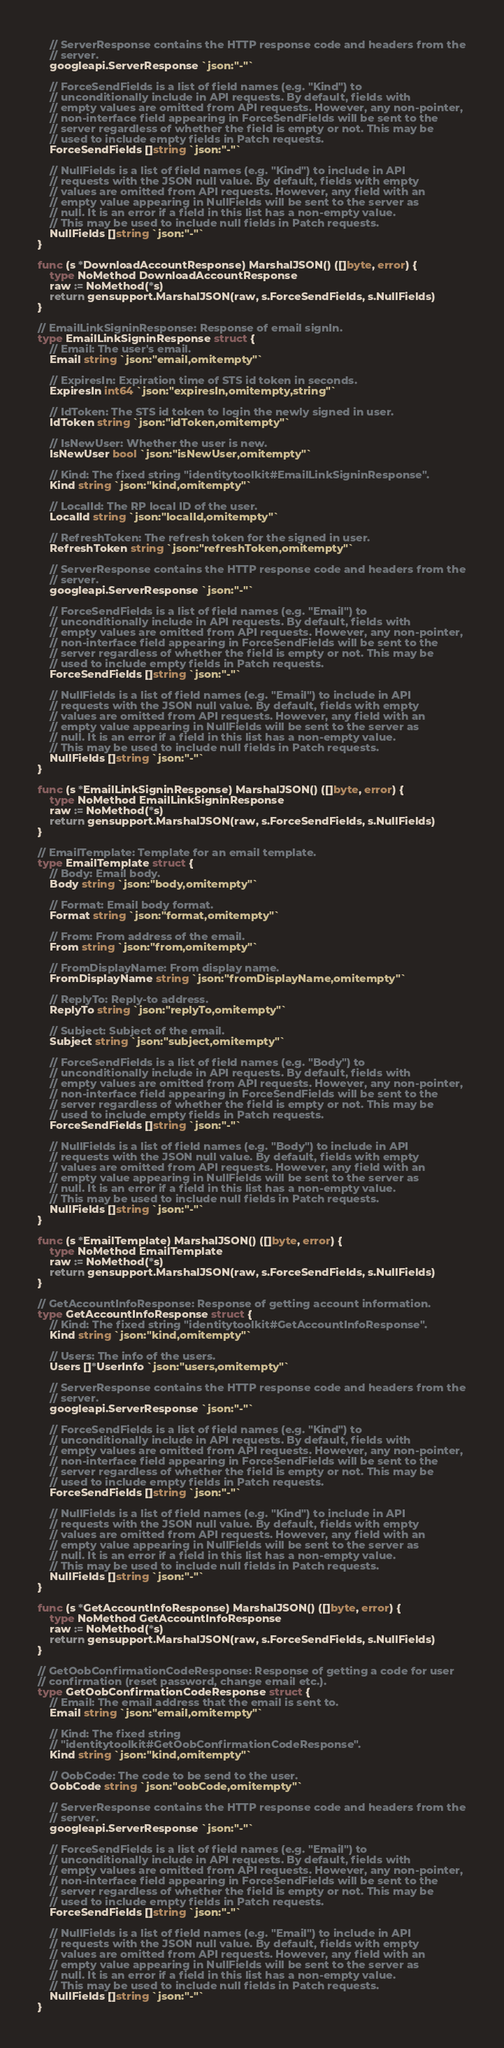Convert code to text. <code><loc_0><loc_0><loc_500><loc_500><_Go_>
	// ServerResponse contains the HTTP response code and headers from the
	// server.
	googleapi.ServerResponse `json:"-"`

	// ForceSendFields is a list of field names (e.g. "Kind") to
	// unconditionally include in API requests. By default, fields with
	// empty values are omitted from API requests. However, any non-pointer,
	// non-interface field appearing in ForceSendFields will be sent to the
	// server regardless of whether the field is empty or not. This may be
	// used to include empty fields in Patch requests.
	ForceSendFields []string `json:"-"`

	// NullFields is a list of field names (e.g. "Kind") to include in API
	// requests with the JSON null value. By default, fields with empty
	// values are omitted from API requests. However, any field with an
	// empty value appearing in NullFields will be sent to the server as
	// null. It is an error if a field in this list has a non-empty value.
	// This may be used to include null fields in Patch requests.
	NullFields []string `json:"-"`
}

func (s *DownloadAccountResponse) MarshalJSON() ([]byte, error) {
	type NoMethod DownloadAccountResponse
	raw := NoMethod(*s)
	return gensupport.MarshalJSON(raw, s.ForceSendFields, s.NullFields)
}

// EmailLinkSigninResponse: Response of email signIn.
type EmailLinkSigninResponse struct {
	// Email: The user's email.
	Email string `json:"email,omitempty"`

	// ExpiresIn: Expiration time of STS id token in seconds.
	ExpiresIn int64 `json:"expiresIn,omitempty,string"`

	// IdToken: The STS id token to login the newly signed in user.
	IdToken string `json:"idToken,omitempty"`

	// IsNewUser: Whether the user is new.
	IsNewUser bool `json:"isNewUser,omitempty"`

	// Kind: The fixed string "identitytoolkit#EmailLinkSigninResponse".
	Kind string `json:"kind,omitempty"`

	// LocalId: The RP local ID of the user.
	LocalId string `json:"localId,omitempty"`

	// RefreshToken: The refresh token for the signed in user.
	RefreshToken string `json:"refreshToken,omitempty"`

	// ServerResponse contains the HTTP response code and headers from the
	// server.
	googleapi.ServerResponse `json:"-"`

	// ForceSendFields is a list of field names (e.g. "Email") to
	// unconditionally include in API requests. By default, fields with
	// empty values are omitted from API requests. However, any non-pointer,
	// non-interface field appearing in ForceSendFields will be sent to the
	// server regardless of whether the field is empty or not. This may be
	// used to include empty fields in Patch requests.
	ForceSendFields []string `json:"-"`

	// NullFields is a list of field names (e.g. "Email") to include in API
	// requests with the JSON null value. By default, fields with empty
	// values are omitted from API requests. However, any field with an
	// empty value appearing in NullFields will be sent to the server as
	// null. It is an error if a field in this list has a non-empty value.
	// This may be used to include null fields in Patch requests.
	NullFields []string `json:"-"`
}

func (s *EmailLinkSigninResponse) MarshalJSON() ([]byte, error) {
	type NoMethod EmailLinkSigninResponse
	raw := NoMethod(*s)
	return gensupport.MarshalJSON(raw, s.ForceSendFields, s.NullFields)
}

// EmailTemplate: Template for an email template.
type EmailTemplate struct {
	// Body: Email body.
	Body string `json:"body,omitempty"`

	// Format: Email body format.
	Format string `json:"format,omitempty"`

	// From: From address of the email.
	From string `json:"from,omitempty"`

	// FromDisplayName: From display name.
	FromDisplayName string `json:"fromDisplayName,omitempty"`

	// ReplyTo: Reply-to address.
	ReplyTo string `json:"replyTo,omitempty"`

	// Subject: Subject of the email.
	Subject string `json:"subject,omitempty"`

	// ForceSendFields is a list of field names (e.g. "Body") to
	// unconditionally include in API requests. By default, fields with
	// empty values are omitted from API requests. However, any non-pointer,
	// non-interface field appearing in ForceSendFields will be sent to the
	// server regardless of whether the field is empty or not. This may be
	// used to include empty fields in Patch requests.
	ForceSendFields []string `json:"-"`

	// NullFields is a list of field names (e.g. "Body") to include in API
	// requests with the JSON null value. By default, fields with empty
	// values are omitted from API requests. However, any field with an
	// empty value appearing in NullFields will be sent to the server as
	// null. It is an error if a field in this list has a non-empty value.
	// This may be used to include null fields in Patch requests.
	NullFields []string `json:"-"`
}

func (s *EmailTemplate) MarshalJSON() ([]byte, error) {
	type NoMethod EmailTemplate
	raw := NoMethod(*s)
	return gensupport.MarshalJSON(raw, s.ForceSendFields, s.NullFields)
}

// GetAccountInfoResponse: Response of getting account information.
type GetAccountInfoResponse struct {
	// Kind: The fixed string "identitytoolkit#GetAccountInfoResponse".
	Kind string `json:"kind,omitempty"`

	// Users: The info of the users.
	Users []*UserInfo `json:"users,omitempty"`

	// ServerResponse contains the HTTP response code and headers from the
	// server.
	googleapi.ServerResponse `json:"-"`

	// ForceSendFields is a list of field names (e.g. "Kind") to
	// unconditionally include in API requests. By default, fields with
	// empty values are omitted from API requests. However, any non-pointer,
	// non-interface field appearing in ForceSendFields will be sent to the
	// server regardless of whether the field is empty or not. This may be
	// used to include empty fields in Patch requests.
	ForceSendFields []string `json:"-"`

	// NullFields is a list of field names (e.g. "Kind") to include in API
	// requests with the JSON null value. By default, fields with empty
	// values are omitted from API requests. However, any field with an
	// empty value appearing in NullFields will be sent to the server as
	// null. It is an error if a field in this list has a non-empty value.
	// This may be used to include null fields in Patch requests.
	NullFields []string `json:"-"`
}

func (s *GetAccountInfoResponse) MarshalJSON() ([]byte, error) {
	type NoMethod GetAccountInfoResponse
	raw := NoMethod(*s)
	return gensupport.MarshalJSON(raw, s.ForceSendFields, s.NullFields)
}

// GetOobConfirmationCodeResponse: Response of getting a code for user
// confirmation (reset password, change email etc.).
type GetOobConfirmationCodeResponse struct {
	// Email: The email address that the email is sent to.
	Email string `json:"email,omitempty"`

	// Kind: The fixed string
	// "identitytoolkit#GetOobConfirmationCodeResponse".
	Kind string `json:"kind,omitempty"`

	// OobCode: The code to be send to the user.
	OobCode string `json:"oobCode,omitempty"`

	// ServerResponse contains the HTTP response code and headers from the
	// server.
	googleapi.ServerResponse `json:"-"`

	// ForceSendFields is a list of field names (e.g. "Email") to
	// unconditionally include in API requests. By default, fields with
	// empty values are omitted from API requests. However, any non-pointer,
	// non-interface field appearing in ForceSendFields will be sent to the
	// server regardless of whether the field is empty or not. This may be
	// used to include empty fields in Patch requests.
	ForceSendFields []string `json:"-"`

	// NullFields is a list of field names (e.g. "Email") to include in API
	// requests with the JSON null value. By default, fields with empty
	// values are omitted from API requests. However, any field with an
	// empty value appearing in NullFields will be sent to the server as
	// null. It is an error if a field in this list has a non-empty value.
	// This may be used to include null fields in Patch requests.
	NullFields []string `json:"-"`
}
</code> 